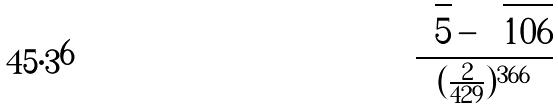<formula> <loc_0><loc_0><loc_500><loc_500>\frac { \sqrt { 5 } - \sqrt { 1 0 6 } } { ( \frac { 2 } { 4 2 9 } ) ^ { 3 6 6 } }</formula> 